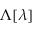Convert formula to latex. <formula><loc_0><loc_0><loc_500><loc_500>\Lambda [ \lambda ]</formula> 